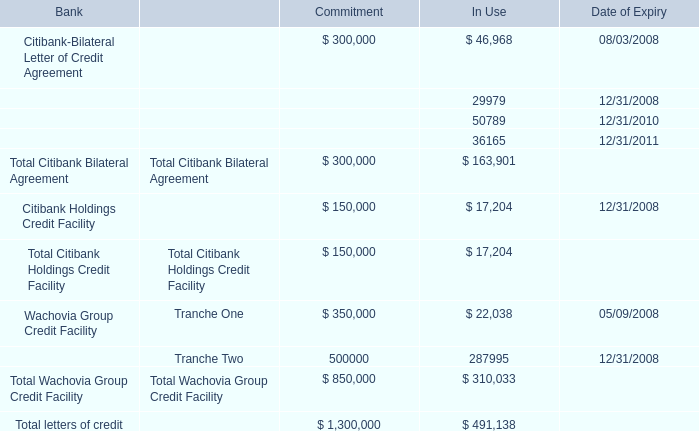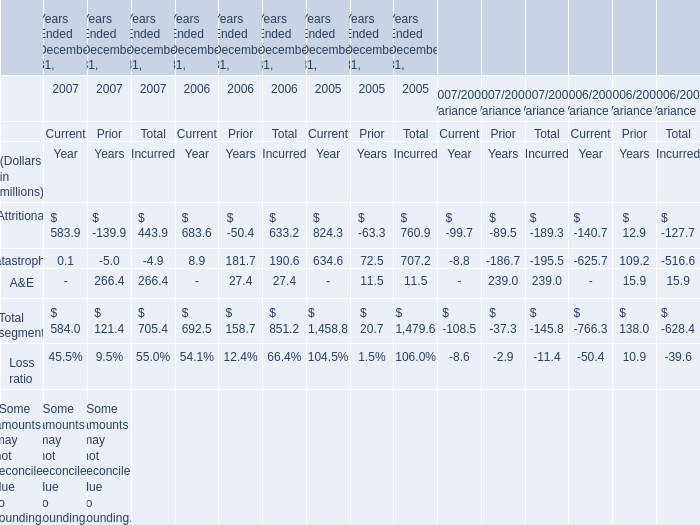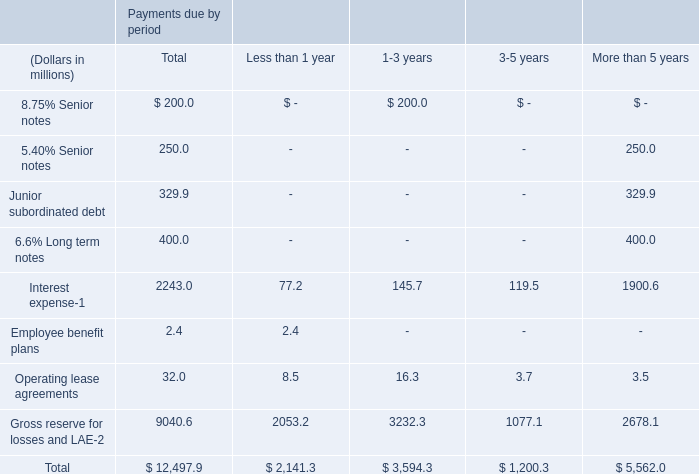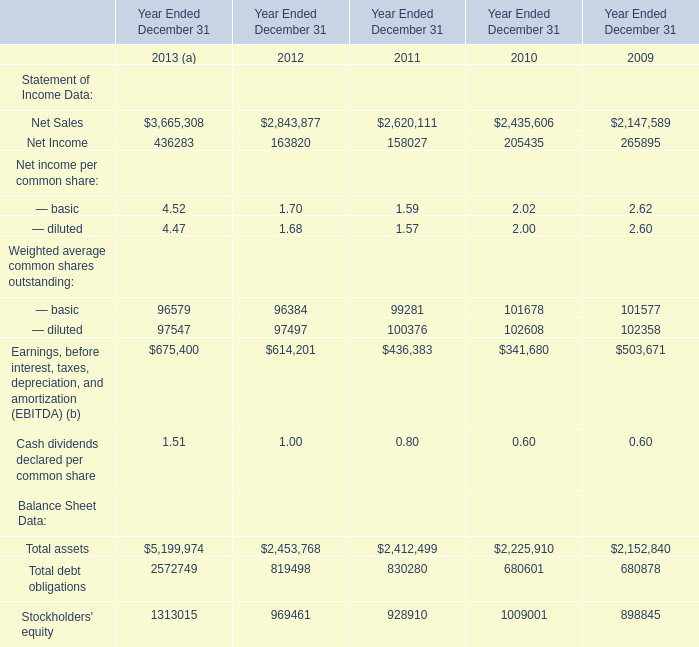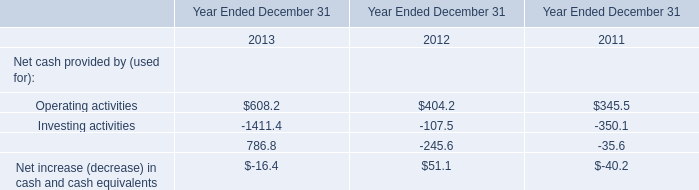what was the rate of increase in 2007 shareholder dividends paid? 
Computations: ((121.4 - 39.0) / 39.0)
Answer: 2.11282. 